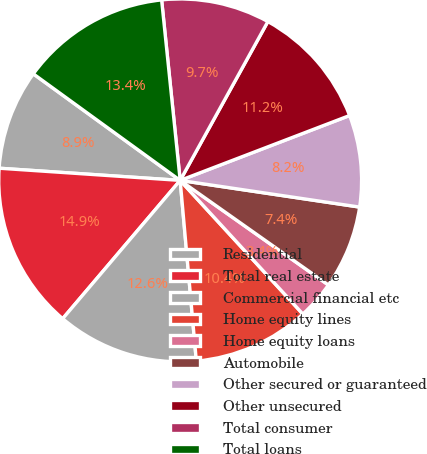Convert chart. <chart><loc_0><loc_0><loc_500><loc_500><pie_chart><fcel>Residential<fcel>Total real estate<fcel>Commercial financial etc<fcel>Home equity lines<fcel>Home equity loans<fcel>Automobile<fcel>Other secured or guaranteed<fcel>Other unsecured<fcel>Total consumer<fcel>Total loans<nl><fcel>8.92%<fcel>14.86%<fcel>12.63%<fcel>10.4%<fcel>3.4%<fcel>7.43%<fcel>8.17%<fcel>11.15%<fcel>9.66%<fcel>13.38%<nl></chart> 